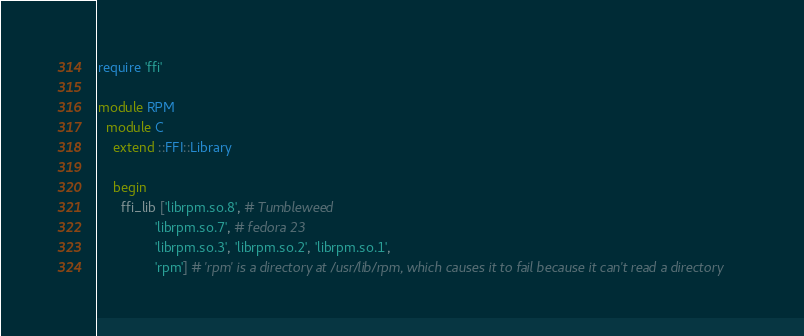Convert code to text. <code><loc_0><loc_0><loc_500><loc_500><_Ruby_>require 'ffi'

module RPM
  module C
    extend ::FFI::Library

    begin
      ffi_lib ['librpm.so.8', # Tumbleweed
               'librpm.so.7', # fedora 23
               'librpm.so.3', 'librpm.so.2', 'librpm.so.1',
               'rpm'] # 'rpm' is a directory at /usr/lib/rpm, which causes it to fail because it can't read a directory</code> 